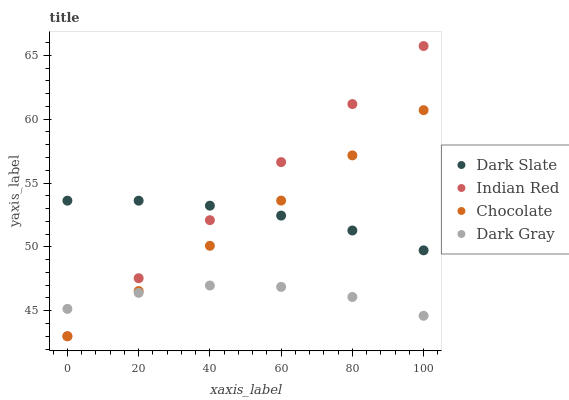Does Dark Gray have the minimum area under the curve?
Answer yes or no. Yes. Does Indian Red have the maximum area under the curve?
Answer yes or no. Yes. Does Dark Slate have the minimum area under the curve?
Answer yes or no. No. Does Dark Slate have the maximum area under the curve?
Answer yes or no. No. Is Indian Red the smoothest?
Answer yes or no. Yes. Is Dark Gray the roughest?
Answer yes or no. Yes. Is Dark Slate the smoothest?
Answer yes or no. No. Is Dark Slate the roughest?
Answer yes or no. No. Does Indian Red have the lowest value?
Answer yes or no. Yes. Does Dark Slate have the lowest value?
Answer yes or no. No. Does Indian Red have the highest value?
Answer yes or no. Yes. Does Dark Slate have the highest value?
Answer yes or no. No. Is Dark Gray less than Dark Slate?
Answer yes or no. Yes. Is Dark Slate greater than Dark Gray?
Answer yes or no. Yes. Does Chocolate intersect Indian Red?
Answer yes or no. Yes. Is Chocolate less than Indian Red?
Answer yes or no. No. Is Chocolate greater than Indian Red?
Answer yes or no. No. Does Dark Gray intersect Dark Slate?
Answer yes or no. No. 